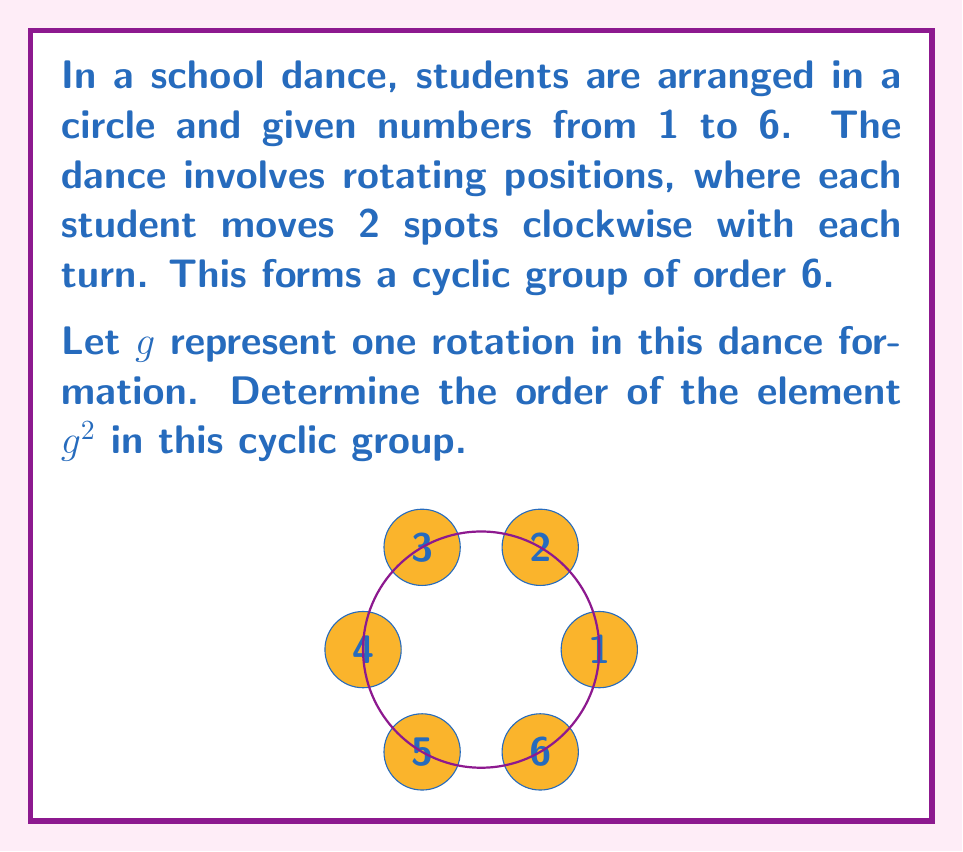What is the answer to this math problem? Let's approach this step-by-step:

1) First, recall that in a cyclic group, the order of an element is the smallest positive integer $k$ such that $g^k = e$, where $e$ is the identity element.

2) In this case, $g$ represents a rotation of 2 spots clockwise. So $g^2$ represents a rotation of 4 spots clockwise.

3) Let's see what happens when we apply $g^2$ multiple times:
   
   $(g^2)^1$: Rotate 4 spots (4 mod 6 = 4)
   $(g^2)^2$: Rotate 8 spots (8 mod 6 = 2)
   $(g^2)^3$: Rotate 12 spots (12 mod 6 = 0)

4) We see that $(g^2)^3$ brings us back to the starting position, which is the identity element.

5) Therefore, the smallest positive integer $k$ such that $(g^2)^k = e$ is 3.

6) This means the order of $g^2$ is 3.
Answer: $3$ 